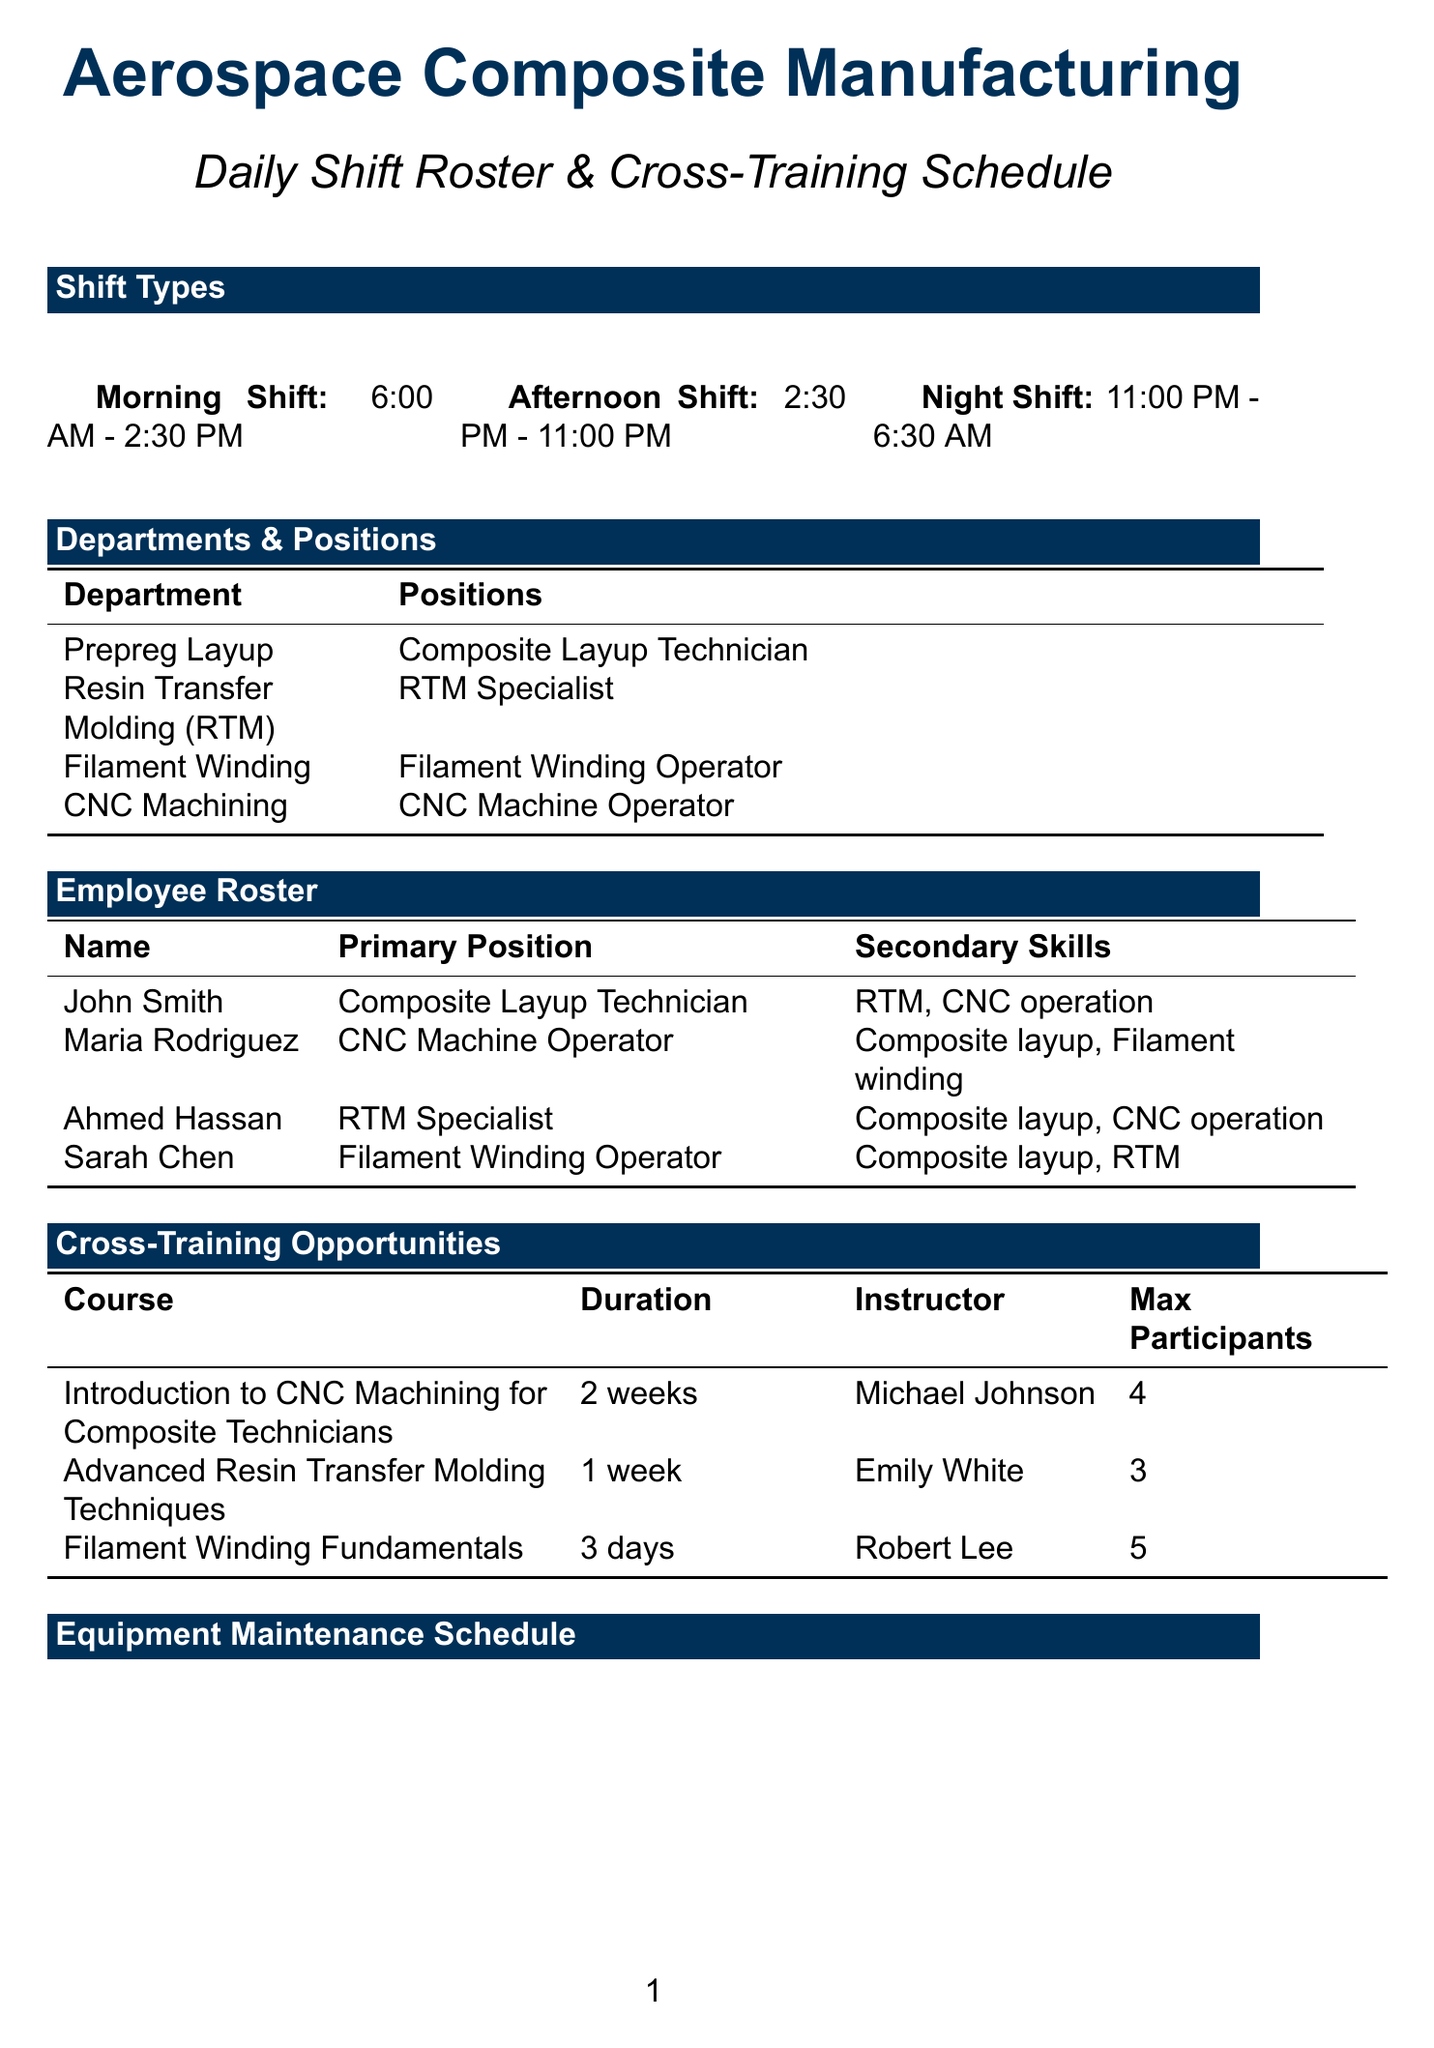What are the hours for the Morning Shift? The hours for Morning Shift are specified in the document as 6:00 AM - 2:30 PM.
Answer: 6:00 AM - 2:30 PM Who is the instructor for the Introduction to CNC Machining for Composite Technicians course? The document lists Michael Johnson as the instructor for this course.
Answer: Michael Johnson How many employees have composite layup skills? By reviewing the employee roster, we find that John Smith, Ahmed Hassan, and Sarah Chen possess composite layup skills, totaling three individuals.
Answer: 3 What is the maximum number of participants for Advanced Resin Transfer Molding Techniques? The document specifies that the maximum number of participants for this course is three.
Answer: 3 Which equipment type requires weekly maintenance? The CNC Router X500 is specified as a 5-Axis CNC Machine that requires weekly maintenance.
Answer: 5-Axis CNC Machine What is the deadline for the Airbus A350 Fuselage Panels project? The document states the deadline for this project as November 15, 2023.
Answer: November 15, 2023 Who is responsible for the daily check of PPE usage? According to the safety protocols section, the Shift Supervisor is responsible for this daily check.
Answer: Shift Supervisor What is the duration of the Filament Winding Fundamentals course? The document mentions that the duration for this course is three days.
Answer: 3 days 